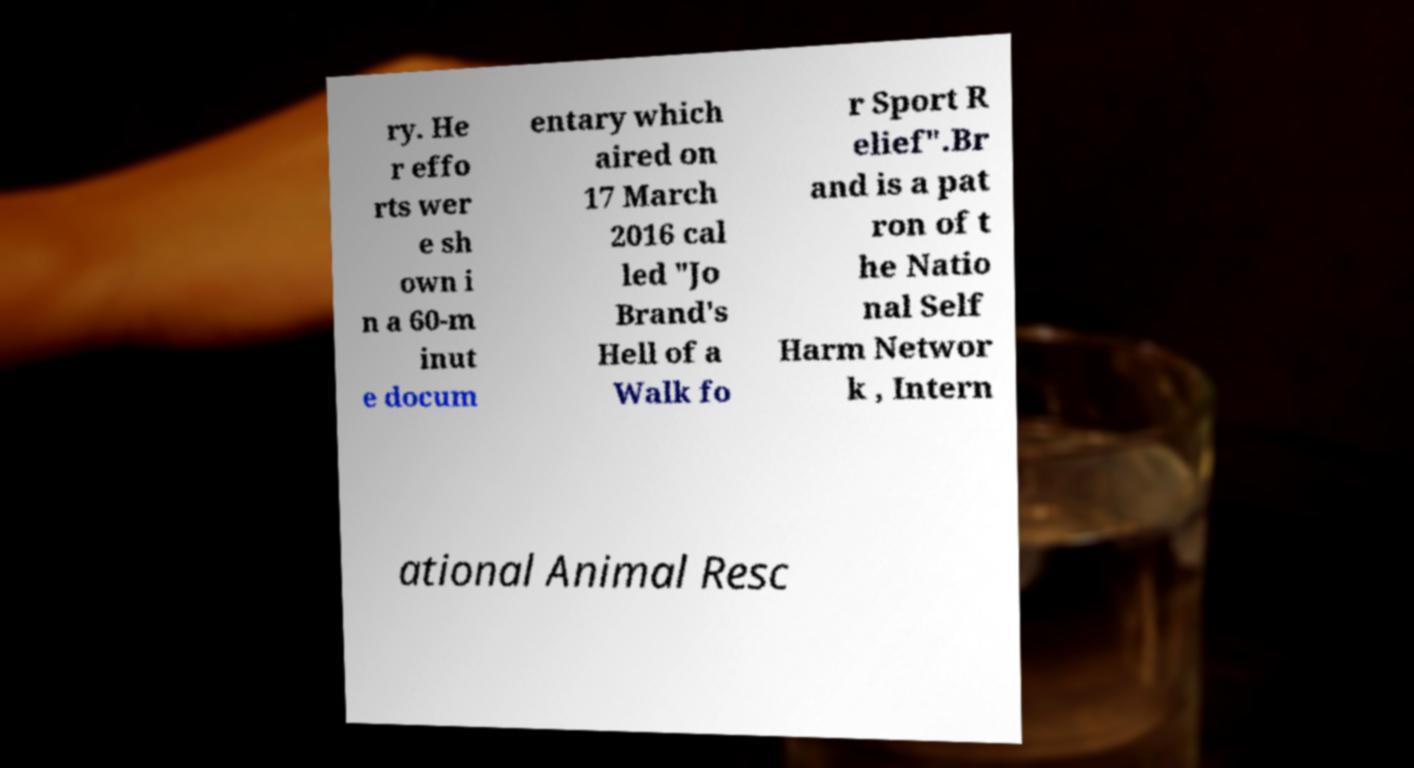Can you read and provide the text displayed in the image?This photo seems to have some interesting text. Can you extract and type it out for me? ry. He r effo rts wer e sh own i n a 60-m inut e docum entary which aired on 17 March 2016 cal led "Jo Brand's Hell of a Walk fo r Sport R elief".Br and is a pat ron of t he Natio nal Self Harm Networ k , Intern ational Animal Resc 